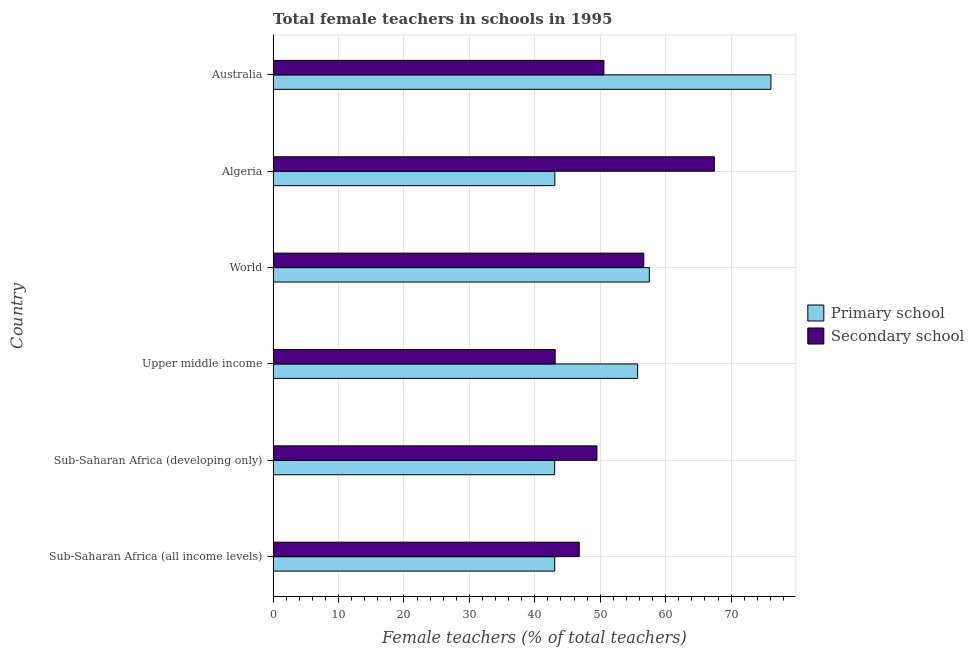How many groups of bars are there?
Provide a succinct answer. 6. Are the number of bars per tick equal to the number of legend labels?
Your answer should be compact. Yes. How many bars are there on the 3rd tick from the top?
Your answer should be very brief. 2. In how many cases, is the number of bars for a given country not equal to the number of legend labels?
Your answer should be compact. 0. What is the percentage of female teachers in secondary schools in Upper middle income?
Provide a short and direct response. 43.11. Across all countries, what is the maximum percentage of female teachers in secondary schools?
Make the answer very short. 67.44. Across all countries, what is the minimum percentage of female teachers in primary schools?
Give a very brief answer. 43.04. In which country was the percentage of female teachers in primary schools minimum?
Offer a terse response. Sub-Saharan Africa (developing only). What is the total percentage of female teachers in primary schools in the graph?
Your response must be concise. 318.45. What is the difference between the percentage of female teachers in secondary schools in Sub-Saharan Africa (all income levels) and that in Sub-Saharan Africa (developing only)?
Keep it short and to the point. -2.7. What is the difference between the percentage of female teachers in secondary schools in Australia and the percentage of female teachers in primary schools in Algeria?
Provide a short and direct response. 7.5. What is the average percentage of female teachers in secondary schools per country?
Ensure brevity in your answer.  52.34. What is the difference between the percentage of female teachers in primary schools and percentage of female teachers in secondary schools in Sub-Saharan Africa (developing only)?
Provide a short and direct response. -6.46. What is the ratio of the percentage of female teachers in primary schools in Australia to that in World?
Offer a terse response. 1.32. Is the percentage of female teachers in secondary schools in Upper middle income less than that in World?
Offer a very short reply. Yes. Is the difference between the percentage of female teachers in primary schools in Algeria and Sub-Saharan Africa (all income levels) greater than the difference between the percentage of female teachers in secondary schools in Algeria and Sub-Saharan Africa (all income levels)?
Your answer should be compact. No. What is the difference between the highest and the second highest percentage of female teachers in primary schools?
Offer a terse response. 18.58. What is the difference between the highest and the lowest percentage of female teachers in secondary schools?
Offer a terse response. 24.33. In how many countries, is the percentage of female teachers in secondary schools greater than the average percentage of female teachers in secondary schools taken over all countries?
Offer a very short reply. 2. Is the sum of the percentage of female teachers in primary schools in Algeria and Sub-Saharan Africa (all income levels) greater than the maximum percentage of female teachers in secondary schools across all countries?
Provide a succinct answer. Yes. What does the 1st bar from the top in Upper middle income represents?
Keep it short and to the point. Secondary school. What does the 1st bar from the bottom in Sub-Saharan Africa (all income levels) represents?
Your response must be concise. Primary school. How many bars are there?
Your response must be concise. 12. Are all the bars in the graph horizontal?
Your answer should be compact. Yes. What is the difference between two consecutive major ticks on the X-axis?
Your answer should be very brief. 10. Does the graph contain any zero values?
Give a very brief answer. No. Does the graph contain grids?
Offer a very short reply. Yes. Where does the legend appear in the graph?
Your answer should be very brief. Center right. How many legend labels are there?
Provide a succinct answer. 2. How are the legend labels stacked?
Offer a very short reply. Vertical. What is the title of the graph?
Give a very brief answer. Total female teachers in schools in 1995. What is the label or title of the X-axis?
Keep it short and to the point. Female teachers (% of total teachers). What is the label or title of the Y-axis?
Give a very brief answer. Country. What is the Female teachers (% of total teachers) in Primary school in Sub-Saharan Africa (all income levels)?
Provide a succinct answer. 43.04. What is the Female teachers (% of total teachers) of Secondary school in Sub-Saharan Africa (all income levels)?
Give a very brief answer. 46.79. What is the Female teachers (% of total teachers) of Primary school in Sub-Saharan Africa (developing only)?
Keep it short and to the point. 43.04. What is the Female teachers (% of total teachers) of Secondary school in Sub-Saharan Africa (developing only)?
Provide a succinct answer. 49.49. What is the Female teachers (% of total teachers) in Primary school in Upper middle income?
Provide a succinct answer. 55.71. What is the Female teachers (% of total teachers) of Secondary school in Upper middle income?
Keep it short and to the point. 43.11. What is the Female teachers (% of total teachers) of Primary school in World?
Offer a terse response. 57.51. What is the Female teachers (% of total teachers) in Secondary school in World?
Make the answer very short. 56.65. What is the Female teachers (% of total teachers) in Primary school in Algeria?
Provide a succinct answer. 43.06. What is the Female teachers (% of total teachers) of Secondary school in Algeria?
Offer a very short reply. 67.44. What is the Female teachers (% of total teachers) of Primary school in Australia?
Your response must be concise. 76.09. What is the Female teachers (% of total teachers) in Secondary school in Australia?
Provide a succinct answer. 50.56. Across all countries, what is the maximum Female teachers (% of total teachers) in Primary school?
Provide a short and direct response. 76.09. Across all countries, what is the maximum Female teachers (% of total teachers) in Secondary school?
Provide a succinct answer. 67.44. Across all countries, what is the minimum Female teachers (% of total teachers) of Primary school?
Offer a very short reply. 43.04. Across all countries, what is the minimum Female teachers (% of total teachers) in Secondary school?
Your answer should be very brief. 43.11. What is the total Female teachers (% of total teachers) in Primary school in the graph?
Your response must be concise. 318.45. What is the total Female teachers (% of total teachers) in Secondary school in the graph?
Offer a terse response. 314.05. What is the difference between the Female teachers (% of total teachers) of Primary school in Sub-Saharan Africa (all income levels) and that in Sub-Saharan Africa (developing only)?
Offer a very short reply. 0. What is the difference between the Female teachers (% of total teachers) of Secondary school in Sub-Saharan Africa (all income levels) and that in Sub-Saharan Africa (developing only)?
Your answer should be very brief. -2.7. What is the difference between the Female teachers (% of total teachers) in Primary school in Sub-Saharan Africa (all income levels) and that in Upper middle income?
Provide a succinct answer. -12.68. What is the difference between the Female teachers (% of total teachers) in Secondary school in Sub-Saharan Africa (all income levels) and that in Upper middle income?
Give a very brief answer. 3.68. What is the difference between the Female teachers (% of total teachers) in Primary school in Sub-Saharan Africa (all income levels) and that in World?
Provide a short and direct response. -14.47. What is the difference between the Female teachers (% of total teachers) in Secondary school in Sub-Saharan Africa (all income levels) and that in World?
Make the answer very short. -9.87. What is the difference between the Female teachers (% of total teachers) of Primary school in Sub-Saharan Africa (all income levels) and that in Algeria?
Make the answer very short. -0.02. What is the difference between the Female teachers (% of total teachers) of Secondary school in Sub-Saharan Africa (all income levels) and that in Algeria?
Offer a terse response. -20.65. What is the difference between the Female teachers (% of total teachers) in Primary school in Sub-Saharan Africa (all income levels) and that in Australia?
Give a very brief answer. -33.05. What is the difference between the Female teachers (% of total teachers) of Secondary school in Sub-Saharan Africa (all income levels) and that in Australia?
Provide a short and direct response. -3.77. What is the difference between the Female teachers (% of total teachers) in Primary school in Sub-Saharan Africa (developing only) and that in Upper middle income?
Provide a short and direct response. -12.68. What is the difference between the Female teachers (% of total teachers) of Secondary school in Sub-Saharan Africa (developing only) and that in Upper middle income?
Keep it short and to the point. 6.38. What is the difference between the Female teachers (% of total teachers) of Primary school in Sub-Saharan Africa (developing only) and that in World?
Provide a short and direct response. -14.47. What is the difference between the Female teachers (% of total teachers) in Secondary school in Sub-Saharan Africa (developing only) and that in World?
Ensure brevity in your answer.  -7.16. What is the difference between the Female teachers (% of total teachers) in Primary school in Sub-Saharan Africa (developing only) and that in Algeria?
Your answer should be compact. -0.03. What is the difference between the Female teachers (% of total teachers) in Secondary school in Sub-Saharan Africa (developing only) and that in Algeria?
Provide a succinct answer. -17.95. What is the difference between the Female teachers (% of total teachers) in Primary school in Sub-Saharan Africa (developing only) and that in Australia?
Offer a terse response. -33.05. What is the difference between the Female teachers (% of total teachers) in Secondary school in Sub-Saharan Africa (developing only) and that in Australia?
Give a very brief answer. -1.07. What is the difference between the Female teachers (% of total teachers) of Primary school in Upper middle income and that in World?
Your response must be concise. -1.79. What is the difference between the Female teachers (% of total teachers) of Secondary school in Upper middle income and that in World?
Offer a terse response. -13.54. What is the difference between the Female teachers (% of total teachers) of Primary school in Upper middle income and that in Algeria?
Provide a succinct answer. 12.65. What is the difference between the Female teachers (% of total teachers) in Secondary school in Upper middle income and that in Algeria?
Your response must be concise. -24.33. What is the difference between the Female teachers (% of total teachers) of Primary school in Upper middle income and that in Australia?
Provide a succinct answer. -20.37. What is the difference between the Female teachers (% of total teachers) of Secondary school in Upper middle income and that in Australia?
Provide a succinct answer. -7.45. What is the difference between the Female teachers (% of total teachers) in Primary school in World and that in Algeria?
Ensure brevity in your answer.  14.44. What is the difference between the Female teachers (% of total teachers) in Secondary school in World and that in Algeria?
Your response must be concise. -10.79. What is the difference between the Female teachers (% of total teachers) of Primary school in World and that in Australia?
Your answer should be compact. -18.58. What is the difference between the Female teachers (% of total teachers) in Secondary school in World and that in Australia?
Offer a very short reply. 6.09. What is the difference between the Female teachers (% of total teachers) of Primary school in Algeria and that in Australia?
Ensure brevity in your answer.  -33.02. What is the difference between the Female teachers (% of total teachers) of Secondary school in Algeria and that in Australia?
Your response must be concise. 16.88. What is the difference between the Female teachers (% of total teachers) of Primary school in Sub-Saharan Africa (all income levels) and the Female teachers (% of total teachers) of Secondary school in Sub-Saharan Africa (developing only)?
Give a very brief answer. -6.45. What is the difference between the Female teachers (% of total teachers) in Primary school in Sub-Saharan Africa (all income levels) and the Female teachers (% of total teachers) in Secondary school in Upper middle income?
Your response must be concise. -0.07. What is the difference between the Female teachers (% of total teachers) of Primary school in Sub-Saharan Africa (all income levels) and the Female teachers (% of total teachers) of Secondary school in World?
Your answer should be compact. -13.62. What is the difference between the Female teachers (% of total teachers) in Primary school in Sub-Saharan Africa (all income levels) and the Female teachers (% of total teachers) in Secondary school in Algeria?
Your response must be concise. -24.4. What is the difference between the Female teachers (% of total teachers) of Primary school in Sub-Saharan Africa (all income levels) and the Female teachers (% of total teachers) of Secondary school in Australia?
Offer a terse response. -7.52. What is the difference between the Female teachers (% of total teachers) in Primary school in Sub-Saharan Africa (developing only) and the Female teachers (% of total teachers) in Secondary school in Upper middle income?
Make the answer very short. -0.07. What is the difference between the Female teachers (% of total teachers) of Primary school in Sub-Saharan Africa (developing only) and the Female teachers (% of total teachers) of Secondary school in World?
Offer a terse response. -13.62. What is the difference between the Female teachers (% of total teachers) in Primary school in Sub-Saharan Africa (developing only) and the Female teachers (% of total teachers) in Secondary school in Algeria?
Provide a short and direct response. -24.4. What is the difference between the Female teachers (% of total teachers) of Primary school in Sub-Saharan Africa (developing only) and the Female teachers (% of total teachers) of Secondary school in Australia?
Your answer should be very brief. -7.52. What is the difference between the Female teachers (% of total teachers) in Primary school in Upper middle income and the Female teachers (% of total teachers) in Secondary school in World?
Provide a succinct answer. -0.94. What is the difference between the Female teachers (% of total teachers) in Primary school in Upper middle income and the Female teachers (% of total teachers) in Secondary school in Algeria?
Ensure brevity in your answer.  -11.73. What is the difference between the Female teachers (% of total teachers) of Primary school in Upper middle income and the Female teachers (% of total teachers) of Secondary school in Australia?
Provide a short and direct response. 5.15. What is the difference between the Female teachers (% of total teachers) in Primary school in World and the Female teachers (% of total teachers) in Secondary school in Algeria?
Make the answer very short. -9.93. What is the difference between the Female teachers (% of total teachers) in Primary school in World and the Female teachers (% of total teachers) in Secondary school in Australia?
Ensure brevity in your answer.  6.95. What is the difference between the Female teachers (% of total teachers) in Primary school in Algeria and the Female teachers (% of total teachers) in Secondary school in Australia?
Keep it short and to the point. -7.5. What is the average Female teachers (% of total teachers) of Primary school per country?
Your response must be concise. 53.07. What is the average Female teachers (% of total teachers) of Secondary school per country?
Provide a succinct answer. 52.34. What is the difference between the Female teachers (% of total teachers) in Primary school and Female teachers (% of total teachers) in Secondary school in Sub-Saharan Africa (all income levels)?
Your response must be concise. -3.75. What is the difference between the Female teachers (% of total teachers) of Primary school and Female teachers (% of total teachers) of Secondary school in Sub-Saharan Africa (developing only)?
Your answer should be very brief. -6.45. What is the difference between the Female teachers (% of total teachers) in Primary school and Female teachers (% of total teachers) in Secondary school in Upper middle income?
Make the answer very short. 12.6. What is the difference between the Female teachers (% of total teachers) in Primary school and Female teachers (% of total teachers) in Secondary school in World?
Your answer should be compact. 0.85. What is the difference between the Female teachers (% of total teachers) in Primary school and Female teachers (% of total teachers) in Secondary school in Algeria?
Provide a short and direct response. -24.38. What is the difference between the Female teachers (% of total teachers) of Primary school and Female teachers (% of total teachers) of Secondary school in Australia?
Give a very brief answer. 25.53. What is the ratio of the Female teachers (% of total teachers) of Secondary school in Sub-Saharan Africa (all income levels) to that in Sub-Saharan Africa (developing only)?
Offer a very short reply. 0.95. What is the ratio of the Female teachers (% of total teachers) of Primary school in Sub-Saharan Africa (all income levels) to that in Upper middle income?
Provide a short and direct response. 0.77. What is the ratio of the Female teachers (% of total teachers) in Secondary school in Sub-Saharan Africa (all income levels) to that in Upper middle income?
Offer a very short reply. 1.09. What is the ratio of the Female teachers (% of total teachers) of Primary school in Sub-Saharan Africa (all income levels) to that in World?
Make the answer very short. 0.75. What is the ratio of the Female teachers (% of total teachers) of Secondary school in Sub-Saharan Africa (all income levels) to that in World?
Provide a short and direct response. 0.83. What is the ratio of the Female teachers (% of total teachers) in Primary school in Sub-Saharan Africa (all income levels) to that in Algeria?
Make the answer very short. 1. What is the ratio of the Female teachers (% of total teachers) of Secondary school in Sub-Saharan Africa (all income levels) to that in Algeria?
Give a very brief answer. 0.69. What is the ratio of the Female teachers (% of total teachers) in Primary school in Sub-Saharan Africa (all income levels) to that in Australia?
Provide a succinct answer. 0.57. What is the ratio of the Female teachers (% of total teachers) of Secondary school in Sub-Saharan Africa (all income levels) to that in Australia?
Keep it short and to the point. 0.93. What is the ratio of the Female teachers (% of total teachers) of Primary school in Sub-Saharan Africa (developing only) to that in Upper middle income?
Ensure brevity in your answer.  0.77. What is the ratio of the Female teachers (% of total teachers) in Secondary school in Sub-Saharan Africa (developing only) to that in Upper middle income?
Make the answer very short. 1.15. What is the ratio of the Female teachers (% of total teachers) in Primary school in Sub-Saharan Africa (developing only) to that in World?
Keep it short and to the point. 0.75. What is the ratio of the Female teachers (% of total teachers) of Secondary school in Sub-Saharan Africa (developing only) to that in World?
Ensure brevity in your answer.  0.87. What is the ratio of the Female teachers (% of total teachers) in Secondary school in Sub-Saharan Africa (developing only) to that in Algeria?
Make the answer very short. 0.73. What is the ratio of the Female teachers (% of total teachers) in Primary school in Sub-Saharan Africa (developing only) to that in Australia?
Ensure brevity in your answer.  0.57. What is the ratio of the Female teachers (% of total teachers) of Secondary school in Sub-Saharan Africa (developing only) to that in Australia?
Provide a succinct answer. 0.98. What is the ratio of the Female teachers (% of total teachers) in Primary school in Upper middle income to that in World?
Provide a succinct answer. 0.97. What is the ratio of the Female teachers (% of total teachers) of Secondary school in Upper middle income to that in World?
Offer a very short reply. 0.76. What is the ratio of the Female teachers (% of total teachers) of Primary school in Upper middle income to that in Algeria?
Your response must be concise. 1.29. What is the ratio of the Female teachers (% of total teachers) of Secondary school in Upper middle income to that in Algeria?
Ensure brevity in your answer.  0.64. What is the ratio of the Female teachers (% of total teachers) of Primary school in Upper middle income to that in Australia?
Your answer should be compact. 0.73. What is the ratio of the Female teachers (% of total teachers) in Secondary school in Upper middle income to that in Australia?
Ensure brevity in your answer.  0.85. What is the ratio of the Female teachers (% of total teachers) of Primary school in World to that in Algeria?
Your answer should be compact. 1.34. What is the ratio of the Female teachers (% of total teachers) in Secondary school in World to that in Algeria?
Your answer should be compact. 0.84. What is the ratio of the Female teachers (% of total teachers) in Primary school in World to that in Australia?
Make the answer very short. 0.76. What is the ratio of the Female teachers (% of total teachers) in Secondary school in World to that in Australia?
Your response must be concise. 1.12. What is the ratio of the Female teachers (% of total teachers) in Primary school in Algeria to that in Australia?
Ensure brevity in your answer.  0.57. What is the ratio of the Female teachers (% of total teachers) of Secondary school in Algeria to that in Australia?
Offer a terse response. 1.33. What is the difference between the highest and the second highest Female teachers (% of total teachers) of Primary school?
Your response must be concise. 18.58. What is the difference between the highest and the second highest Female teachers (% of total teachers) in Secondary school?
Your response must be concise. 10.79. What is the difference between the highest and the lowest Female teachers (% of total teachers) of Primary school?
Your response must be concise. 33.05. What is the difference between the highest and the lowest Female teachers (% of total teachers) in Secondary school?
Your answer should be compact. 24.33. 